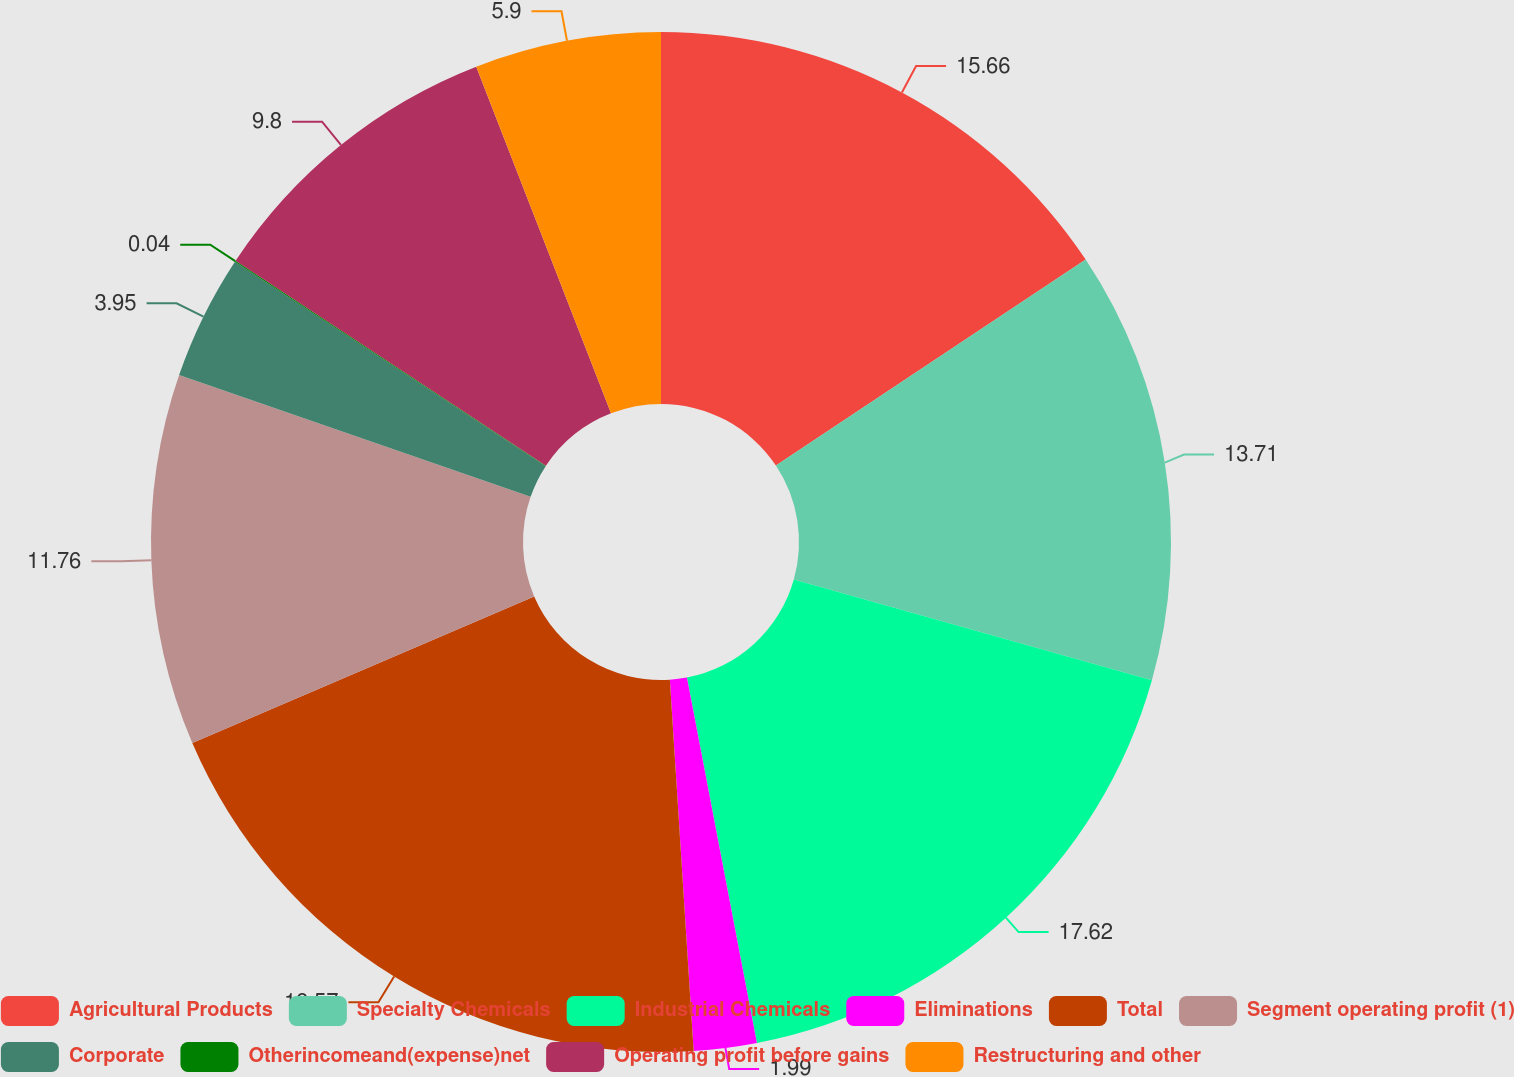Convert chart to OTSL. <chart><loc_0><loc_0><loc_500><loc_500><pie_chart><fcel>Agricultural Products<fcel>Specialty Chemicals<fcel>Industrial Chemicals<fcel>Eliminations<fcel>Total<fcel>Segment operating profit (1)<fcel>Corporate<fcel>Otherincomeand(expense)net<fcel>Operating profit before gains<fcel>Restructuring and other<nl><fcel>15.66%<fcel>13.71%<fcel>17.62%<fcel>1.99%<fcel>19.57%<fcel>11.76%<fcel>3.95%<fcel>0.04%<fcel>9.8%<fcel>5.9%<nl></chart> 